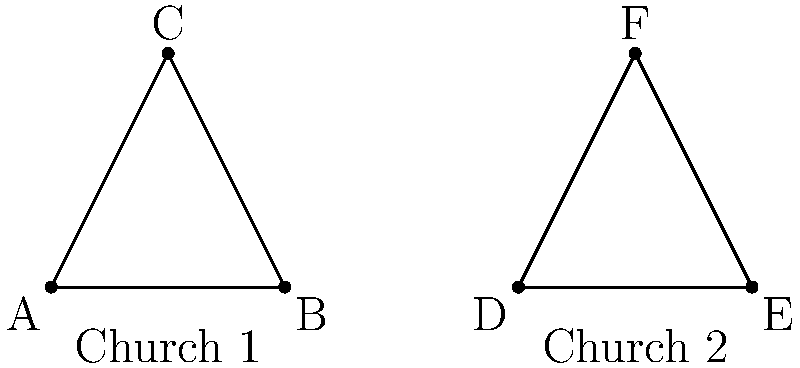Consider the architectural design of two Crusader-built churches represented by the triangles ABC and DEF. If AB = DE and angle BAC = angle EDF, what geometric principle establishes the congruence of these triangular elements? To determine the congruence of the triangular elements in these Crusader-built churches, we need to follow these steps:

1. Identify the given information:
   - AB = DE (one side is equal)
   - ∠BAC = ∠EDF (one angle is equal)

2. Recall the congruence principles for triangles:
   - SSS (Side-Side-Side)
   - SAS (Side-Angle-Side)
   - ASA (Angle-Side-Angle)
   - AAS (Angle-Angle-Side)

3. Analyze the given information:
   - We have one side (AB = DE) and one angle (∠BAC = ∠EDF) that are equal.
   - These equal parts are adjacent to each other (the angle is formed by the equal sides).

4. Match the given information with the congruence principles:
   - The combination of one equal side and one equal adjacent angle matches the SAS (Side-Angle-Side) principle.

5. Apply the SAS principle:
   - If two sides and the included angle of one triangle are equal to the corresponding parts of another triangle, the triangles are congruent.

6. Conclusion:
   - The SAS (Side-Angle-Side) principle establishes the congruence of these triangular elements in the Crusader-built churches.

This congruence principle would be significant in analyzing the architectural consistency across different regions during the Crusades, reflecting the standardization of design elements in religious structures.
Answer: SAS (Side-Angle-Side) principle 